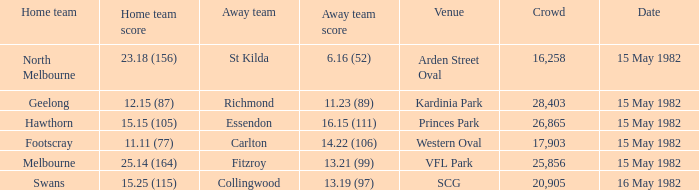Which away team had more than 17,903 spectators and played Melbourne? 13.21 (99). 